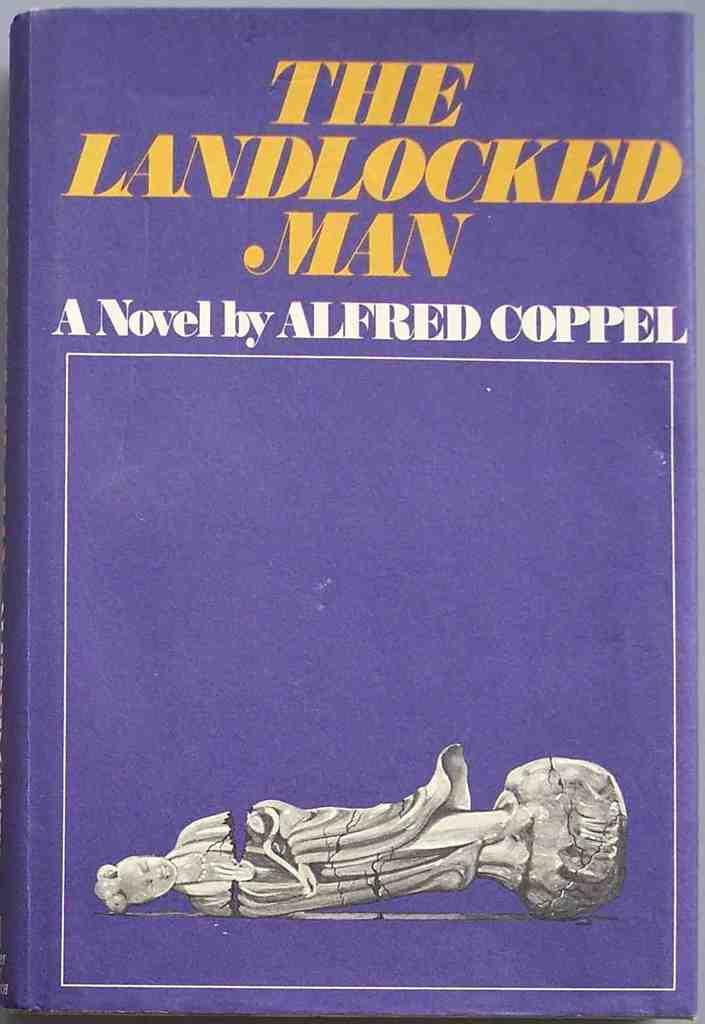Provide a one-sentence caption for the provided image. An Alfred Coppel novel that pictures a broken statue on the cover. 